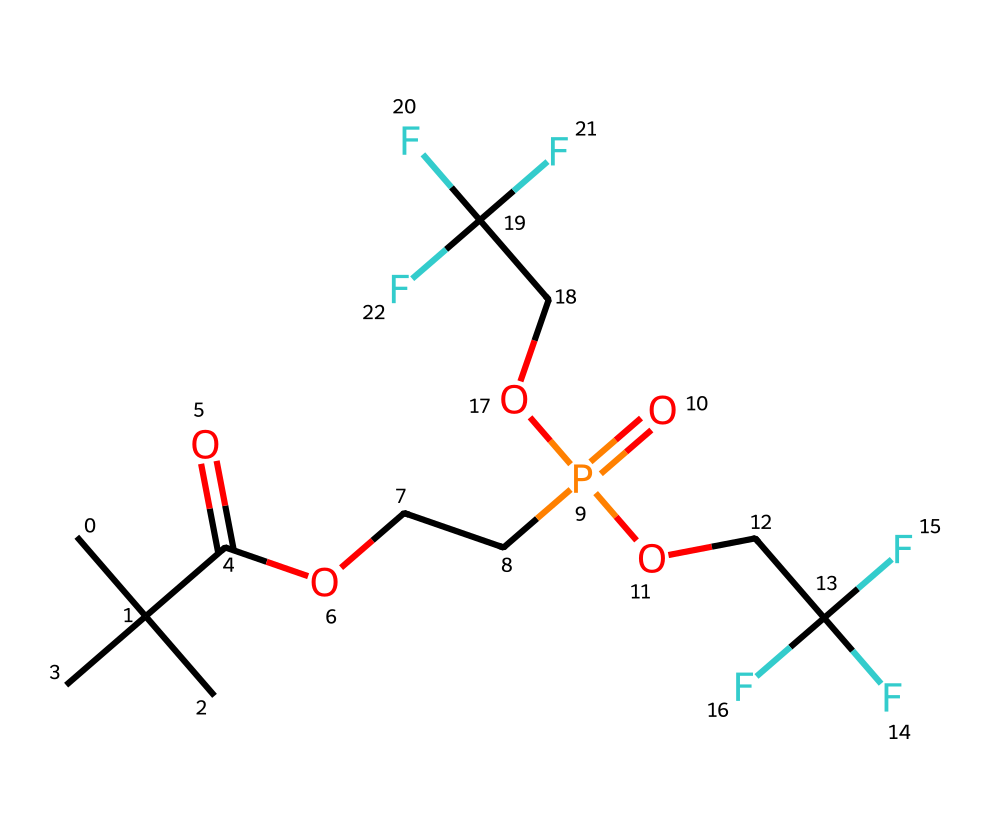what is the central atom in this compound? The central atom of this compound is phosphorus, as indicated by the presence of P in the SMILES representation. The notation shows it's involved in a phosphate group, which is common in many phosphorus compounds.
Answer: phosphorus how many carbon atoms are present in this compound? By analyzing the SMILES, we can count the occurrences of 'C' which indicates carbon atoms. In this case, there are 9 total carbon atoms present.
Answer: 9 what functional groups are present in the molecule? The molecule contains both carboxylic acid (due to -COOH) and phosphate functional groups (due to -P(=O)(O...) presence). These groups can be identified by their distinct patterns in the SMILES notation.
Answer: carboxylic acid, phosphate how many fluorine atoms are present in this compound? The presence of 'F' in the SMILES indicates each fluorine atom. By counting the 'F', we find there are a total of 6 fluorine atoms in this compound.
Answer: 6 what type of phosphorus compound is represented here? This compound represents an organophosphorus compound due to the presence of carbon chains bonded to phosphorus along with the phosphate group, which is characteristic of organophosphorus chemistry.
Answer: organophosphorus what is the maximum degree of branching in the carbon chains? The structural analysis shows the carbon is branched with isobutyl groups, making it tri-substituted, meaning the maximum branching comes from three carbon branches attached to a central carbon atom in one part of the molecule.
Answer: 3 